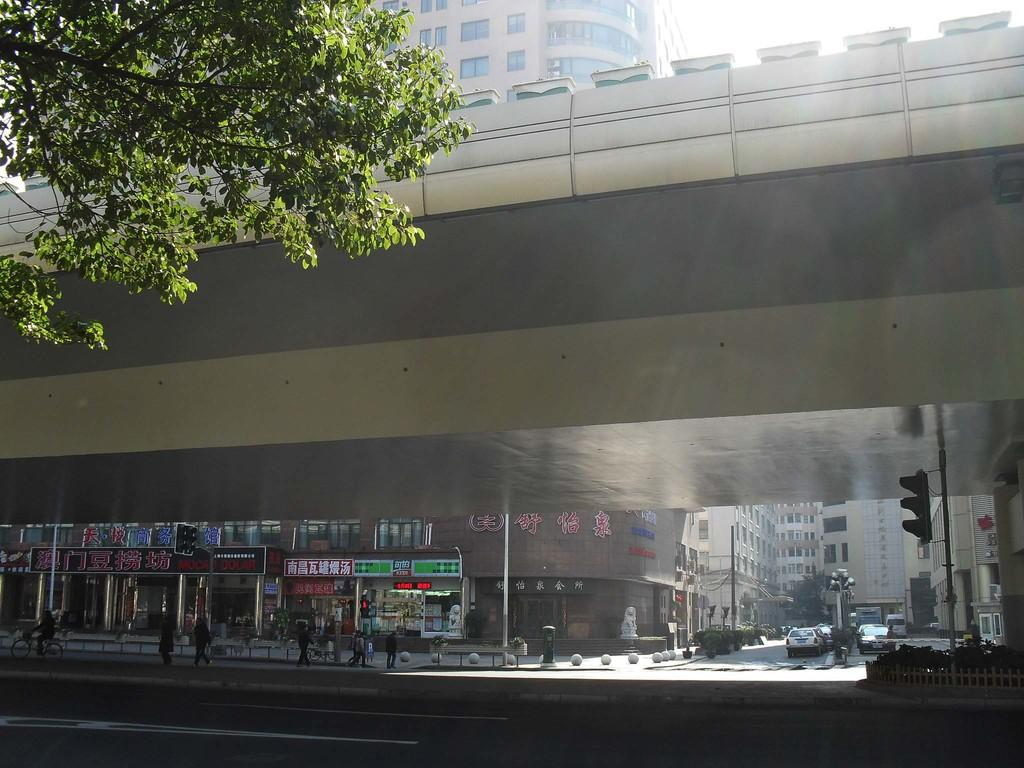How many people are in the image? There is a group of people in the image, but the exact number cannot be determined from the provided facts. What can be seen on the road in the image? There are vehicles on the road in the image. What type of structures are present in the image? There are buildings in the image. What are the signal lights attached to in the image? Signal lights are attached to poles in the image. What type of vegetation is present in the image? There is a tree and plants in the image. What type of infrastructure is present in the image? There is a flyover in the image. What part of the natural environment is visible in the image? The sky is visible in the image. What type of agreement is being signed by the people in the image? There is no indication in the image that the people are signing any agreement. What type of basket is hanging from the tree in the image? There is no basket present in the image; only a tree and plants are mentioned. 